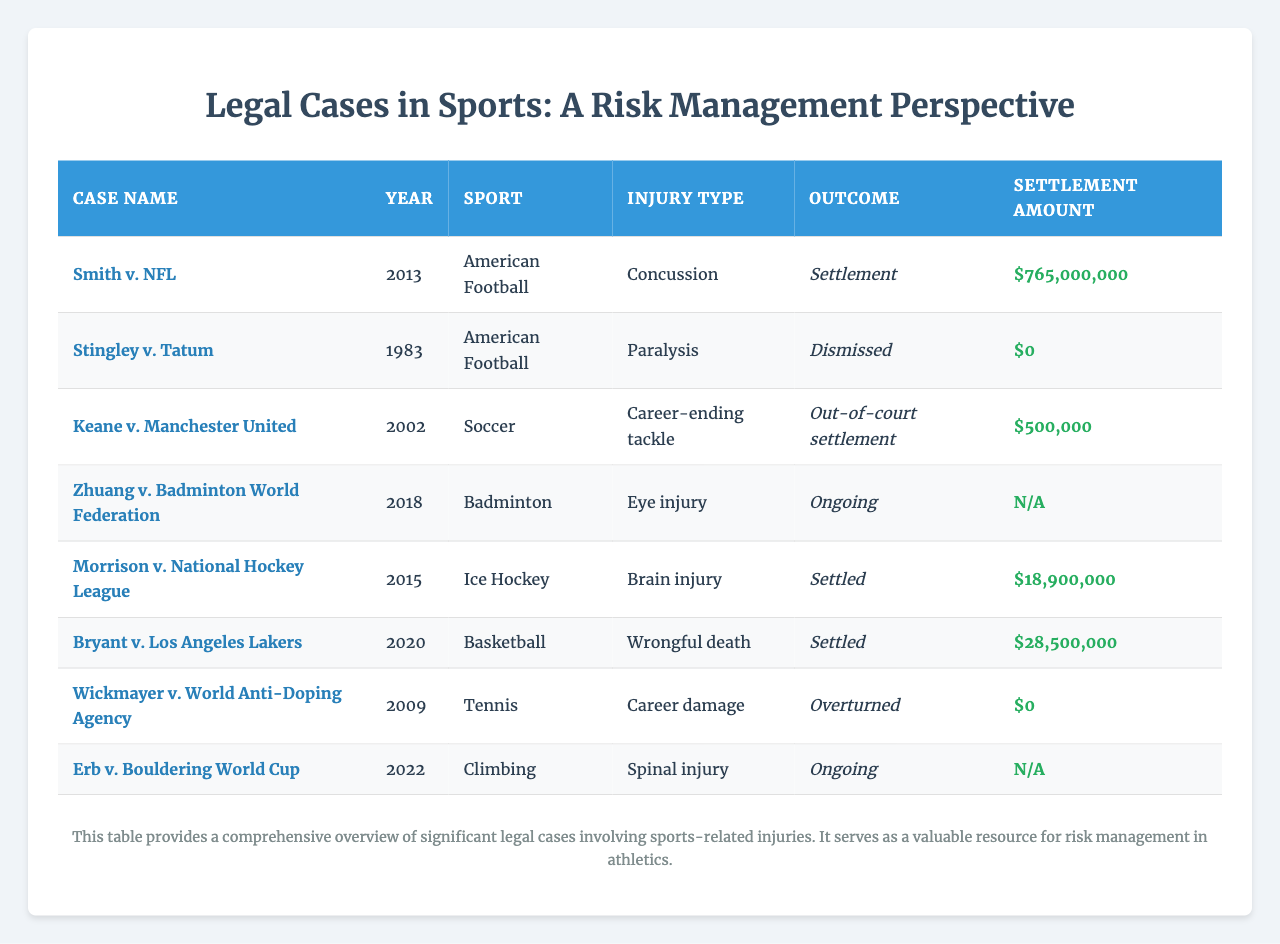What is the highest settlement amount shown in the table? By examining the "Settlement Amount" column, the highest value is from the "Smith v. NFL" case, which is $765,000,000.
Answer: $765,000,000 How many cases resulted in a settlement? The table shows that five cases have an outcome of either "Settlement" or "Out-of-court settlement," specifically: "Smith v. NFL," "Morrison v. National Hockey League," "Bryant v. Los Angeles Lakers," and "Keane v. Manchester United."
Answer: 4 What is the injury type for the case "Bryant v. Los Angeles Lakers"? In the table, the injury type listed for this case is "Wrongful death."
Answer: Wrongful death Are there any cases with an ongoing outcome? Yes, there are two cases with the outcome "Ongoing," specifically: "Zhuang v. Badminton World Federation" and "Erb v. Bouldering World Cup."
Answer: Yes What is the average settlement amount of cases that settled? The settle amount values are $765,000,000, $18,900,000, and $28,500,000. Adding these gives $812,400,000. There are three cases, so the average is $812,400,000 / 3 = $270,800,000.
Answer: $270,800,000 Which sport has the most cases listed? By counting the instances in the "Sport" column, American Football has three cases: "Smith v. NFL," "Stingley v. Tatum," and "Morrison v. National Hockey League," more than any other sport.
Answer: American Football What was the total number of cases recorded in the table? There are a total of eight cases listed in the table, each representing a unique incident involving sports-related injuries.
Answer: 8 Did any cases result in a dismissal? Yes, the case "Stingley v. Tatum" had an outcome of "Dismissed."
Answer: Yes What is the total settlement amount for cases that were settled? The total of the settlements is calculated by adding $765,000,000, $18,900,000, and $28,500,000 which equals $812,400,000.
Answer: $812,400,000 Which injury type resulted in the lowest settlement amount? "Keane v. Manchester United" had the lowest settlement amount at $500,000 for the injury type "Career-ending tackle."
Answer: Career-ending tackle 